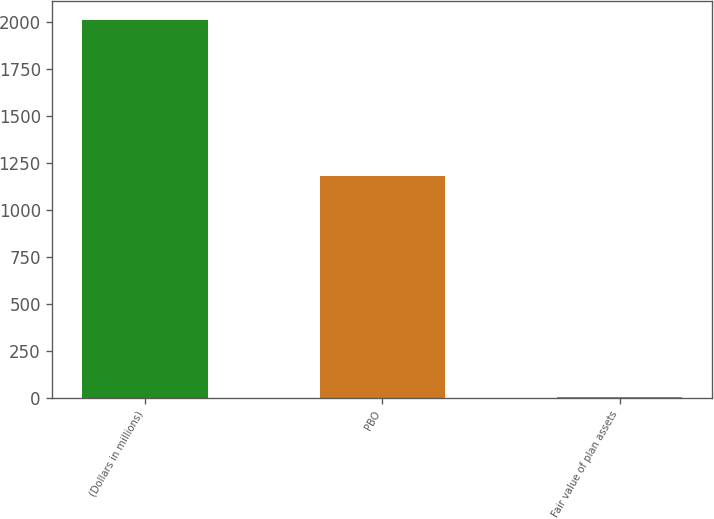Convert chart to OTSL. <chart><loc_0><loc_0><loc_500><loc_500><bar_chart><fcel>(Dollars in millions)<fcel>PBO<fcel>Fair value of plan assets<nl><fcel>2012<fcel>1182<fcel>2<nl></chart> 